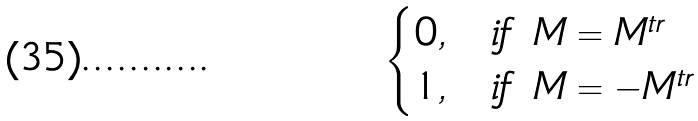Convert formula to latex. <formula><loc_0><loc_0><loc_500><loc_500>\begin{cases} 0 , & i f \ M = M ^ { t r } \\ 1 , & i f \ M = - M ^ { t r } \\ \end{cases}</formula> 